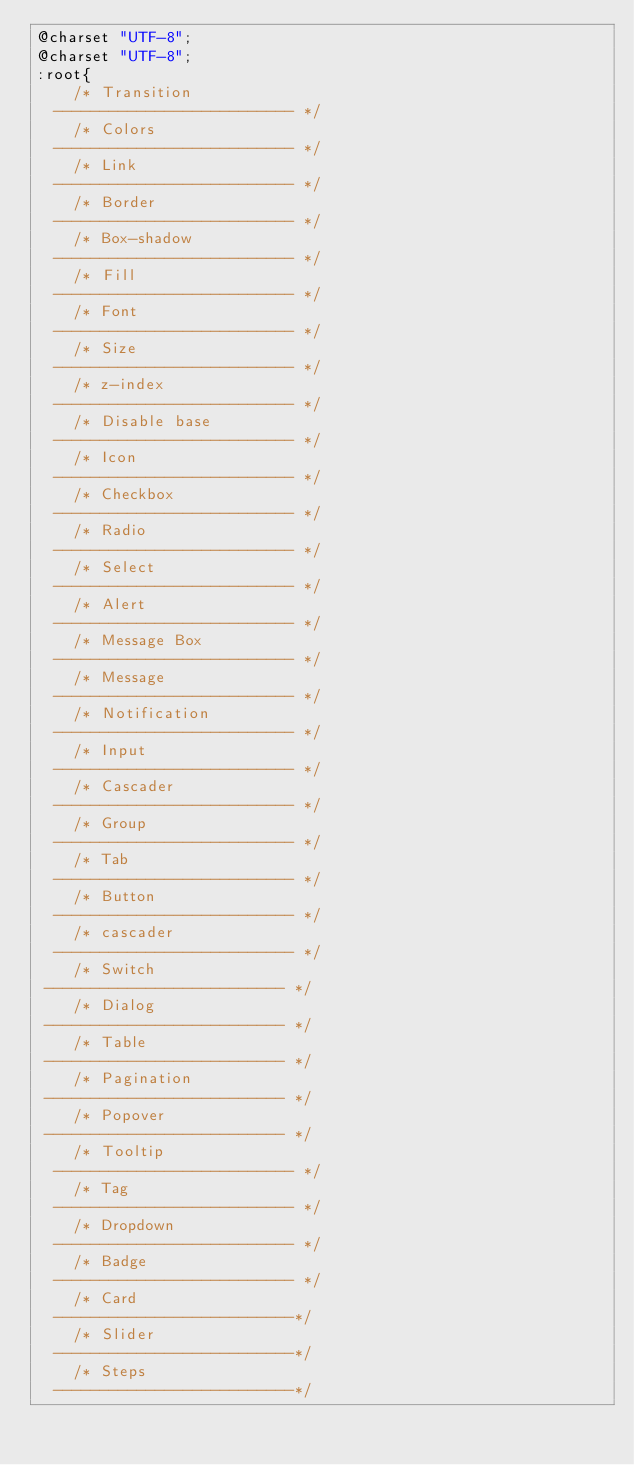Convert code to text. <code><loc_0><loc_0><loc_500><loc_500><_CSS_>@charset "UTF-8";
@charset "UTF-8";
:root{
    /* Transition
  -------------------------- */
    /* Colors
  -------------------------- */
    /* Link
  -------------------------- */
    /* Border
  -------------------------- */
    /* Box-shadow
  -------------------------- */
    /* Fill
  -------------------------- */
    /* Font
  -------------------------- */
    /* Size
  -------------------------- */
    /* z-index
  -------------------------- */
    /* Disable base
  -------------------------- */
    /* Icon
  -------------------------- */
    /* Checkbox
  -------------------------- */
    /* Radio
  -------------------------- */
    /* Select
  -------------------------- */
    /* Alert
  -------------------------- */
    /* Message Box
  -------------------------- */
    /* Message
  -------------------------- */
    /* Notification
  -------------------------- */
    /* Input
  -------------------------- */
    /* Cascader
  -------------------------- */
    /* Group
  -------------------------- */
    /* Tab
  -------------------------- */
    /* Button
  -------------------------- */
    /* cascader
  -------------------------- */
    /* Switch
 -------------------------- */
    /* Dialog
 -------------------------- */
    /* Table
 -------------------------- */
    /* Pagination
 -------------------------- */
    /* Popover
 -------------------------- */
    /* Tooltip
  -------------------------- */
    /* Tag
  -------------------------- */
    /* Dropdown
  -------------------------- */
    /* Badge
  -------------------------- */
    /* Card
  --------------------------*/
    /* Slider
  --------------------------*/
    /* Steps
  --------------------------*/</code> 